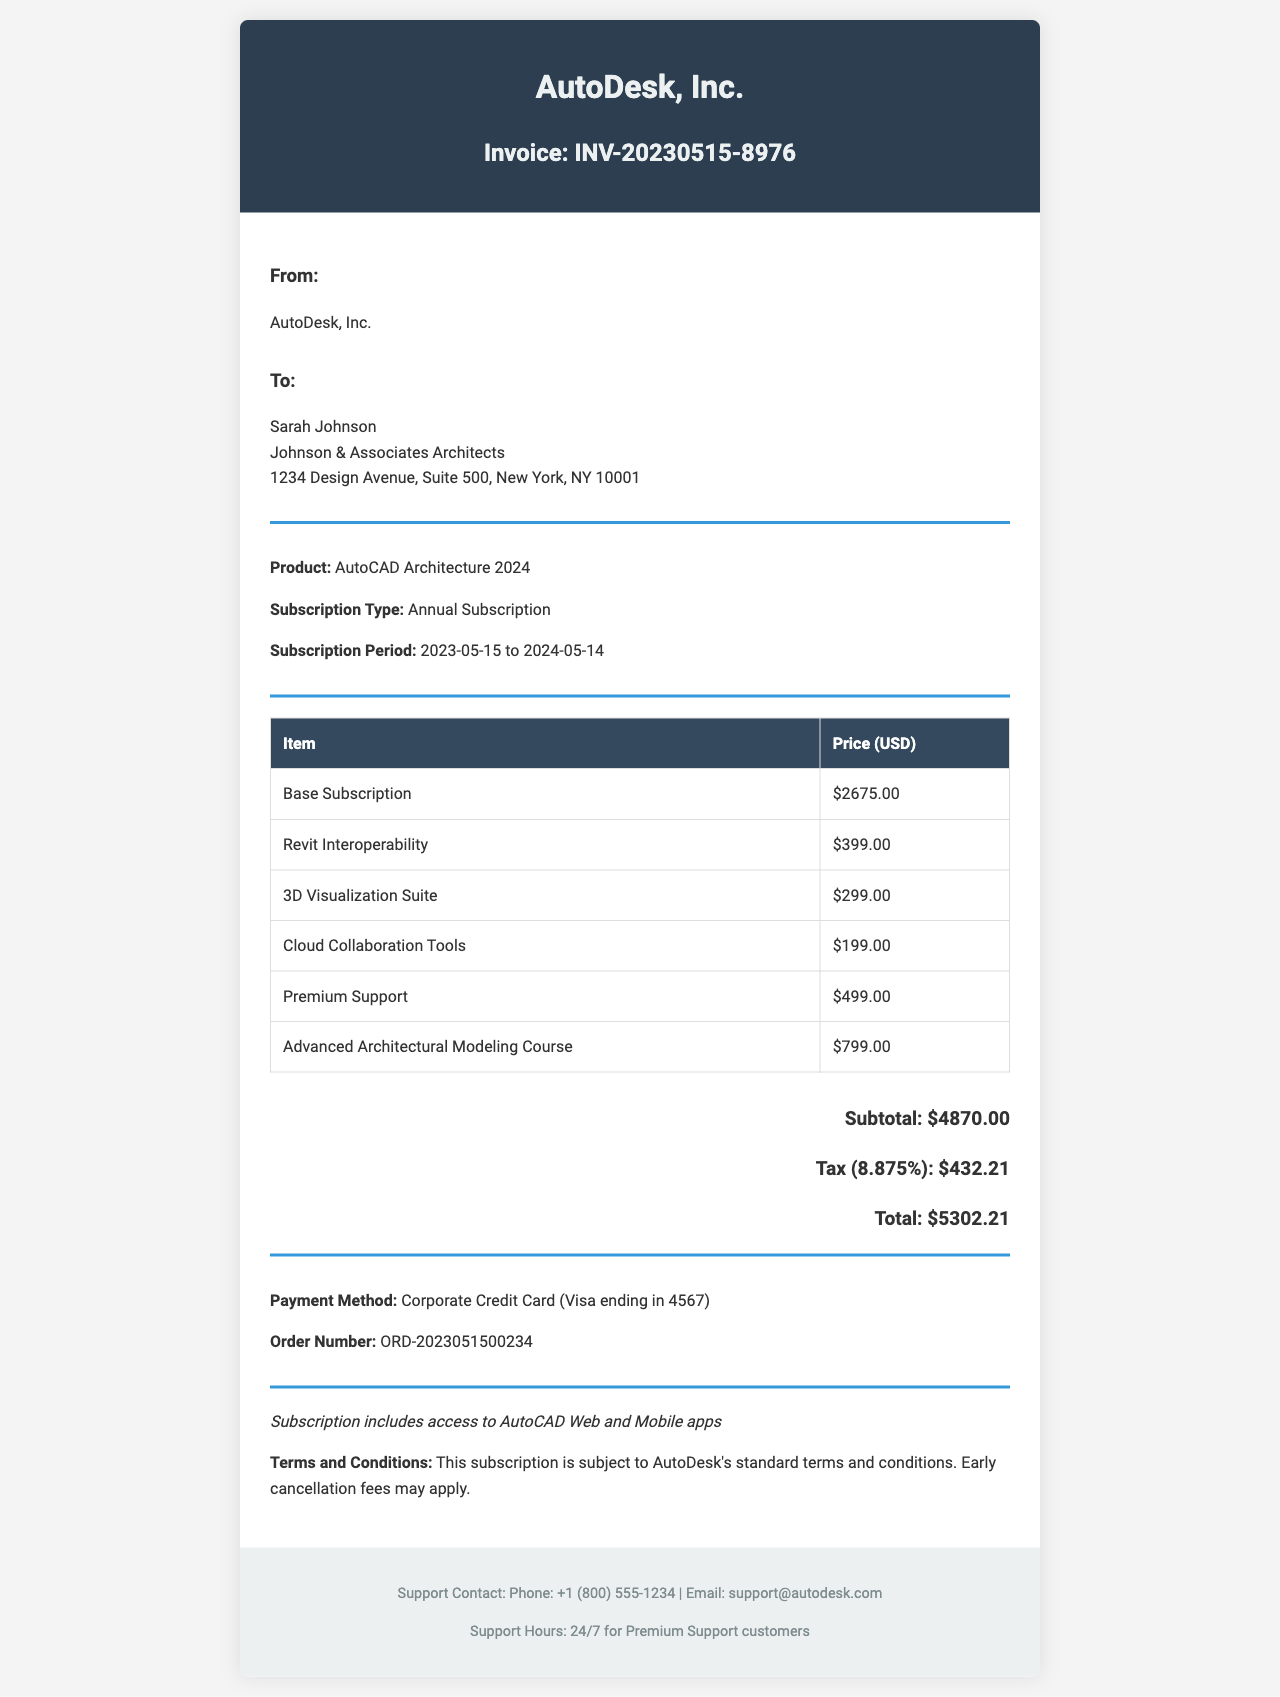What is the invoice number? The invoice number is a unique identifier for this transaction, listed in the document.
Answer: INV-20230515-8976 Who is the customer? The customer is the individual or company receiving the invoice, mentioned in the document.
Answer: Sarah Johnson What is the total amount due? The total amount due is the final sum that needs to be paid, calculated after taxes.
Answer: 5302.21 What is the subscription period? The subscription period specifies the time frame for which the service is provided, detailed in the document.
Answer: 2023-05-15 to 2024-05-14 How much does the Revit Interoperability add-on cost? The cost of this specific add-on feature is listed under additional features in the document.
Answer: 399.00 What payment method was used? The payment method indicates how the transaction was processed, found in the payment details section.
Answer: Corporate Credit Card What support plan is included? The support plan provides information about the type of customer support associated with the invoice.
Answer: Premium Support How much is the tax rate? The tax rate is the percentage applied to the subtotal for calculating the tax amount, specified in the document.
Answer: 8.875% What is included in customer notes? Customer notes provide additional information or remarks regarding the invoice and services offered.
Answer: Subscription includes access to AutoCAD Web and Mobile apps 